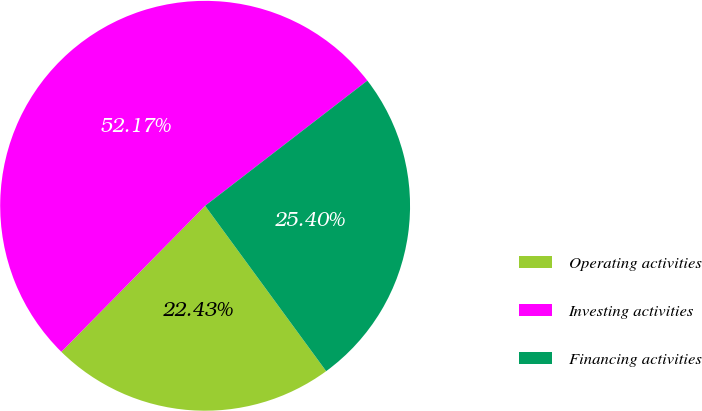Convert chart. <chart><loc_0><loc_0><loc_500><loc_500><pie_chart><fcel>Operating activities<fcel>Investing activities<fcel>Financing activities<nl><fcel>22.43%<fcel>52.16%<fcel>25.4%<nl></chart> 